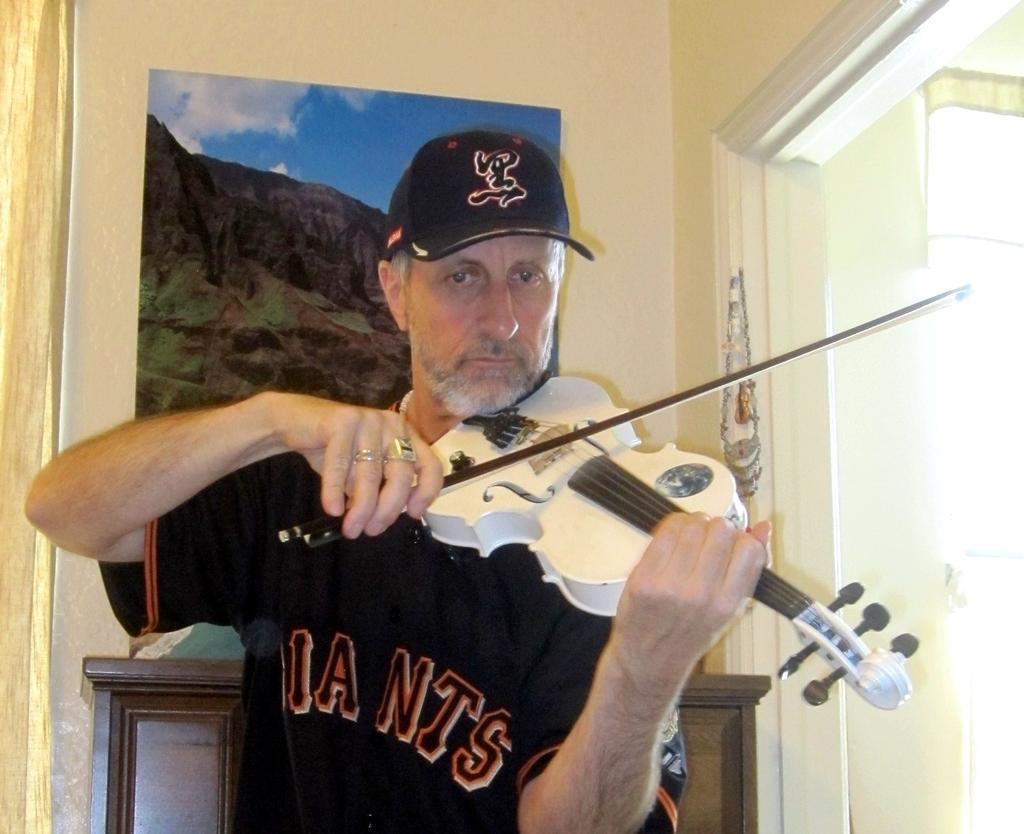Please provide a concise description of this image. In this picture there is a person holding musical instrument. On the background we can see wall,frame. 